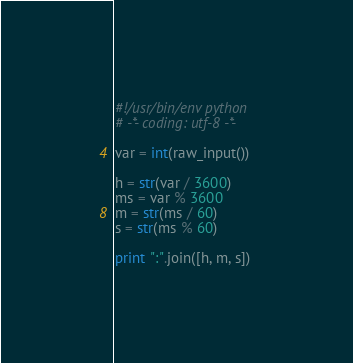<code> <loc_0><loc_0><loc_500><loc_500><_Python_>#!/usr/bin/env python
# -*- coding: utf-8 -*-

var = int(raw_input())

h = str(var / 3600)
ms = var % 3600
m = str(ms / 60)
s = str(ms % 60)

print ":".join([h, m, s])</code> 